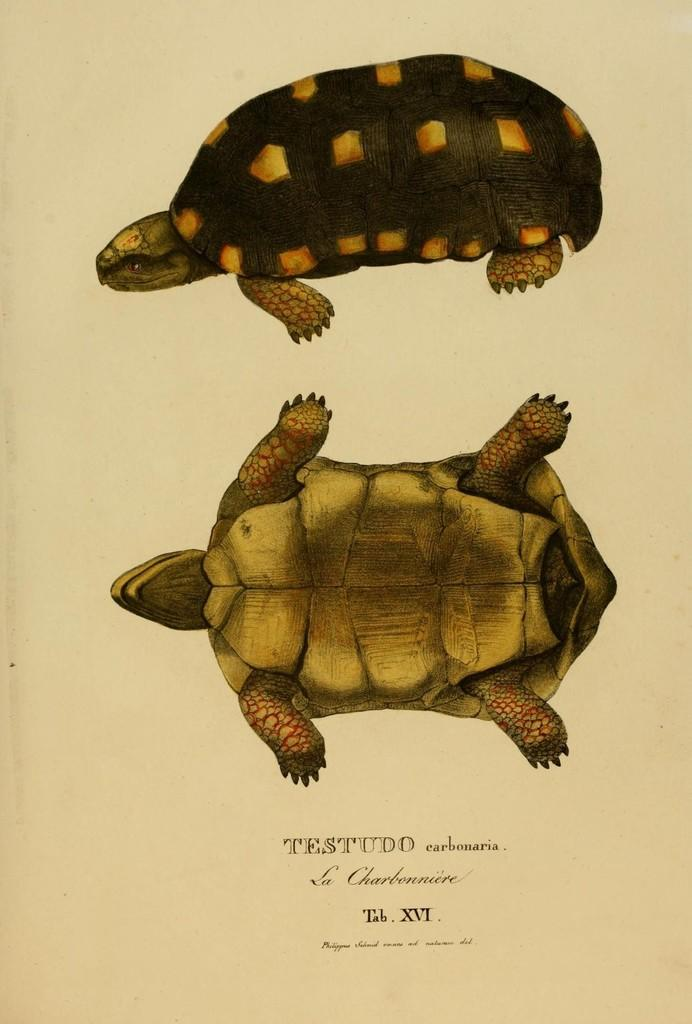What is depicted on the paper in the image? The paper contains two tortoise diagrams. Are both tortoise diagrams facing the same direction? No, one of the tortoise diagrams is upside down. Is there any text on the paper? Yes, there is text printed at the bottom of the paper. What type of reaction can be seen in the image? There is no reaction depicted in the image; it only contains two tortoise diagrams and text. Is there a calculator visible in the image? No, there is no calculator present in the image. 